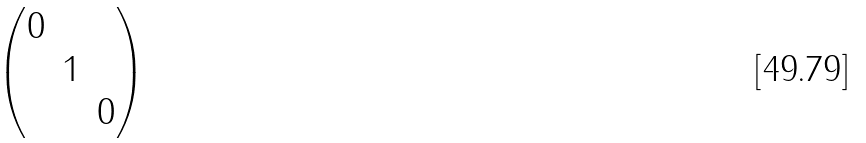<formula> <loc_0><loc_0><loc_500><loc_500>\begin{pmatrix} 0 & & \\ & 1 & \\ & & 0 \end{pmatrix}</formula> 